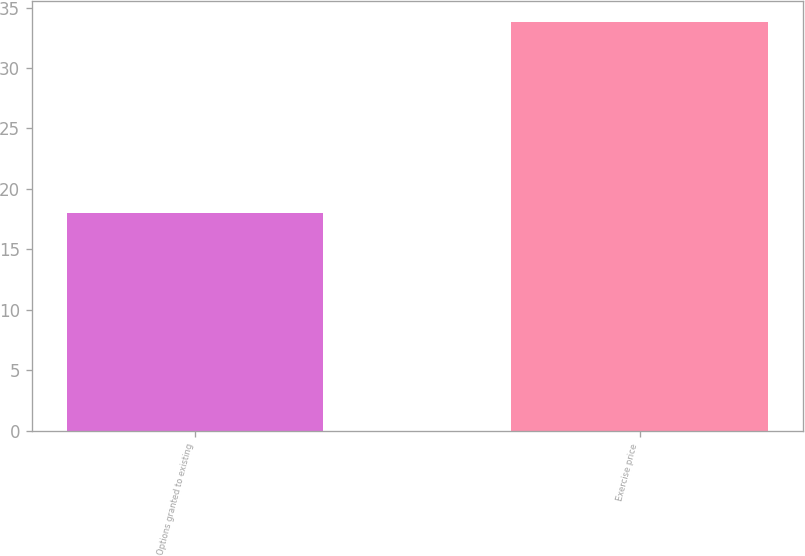Convert chart. <chart><loc_0><loc_0><loc_500><loc_500><bar_chart><fcel>Options granted to existing<fcel>Exercise price<nl><fcel>18<fcel>33.82<nl></chart> 